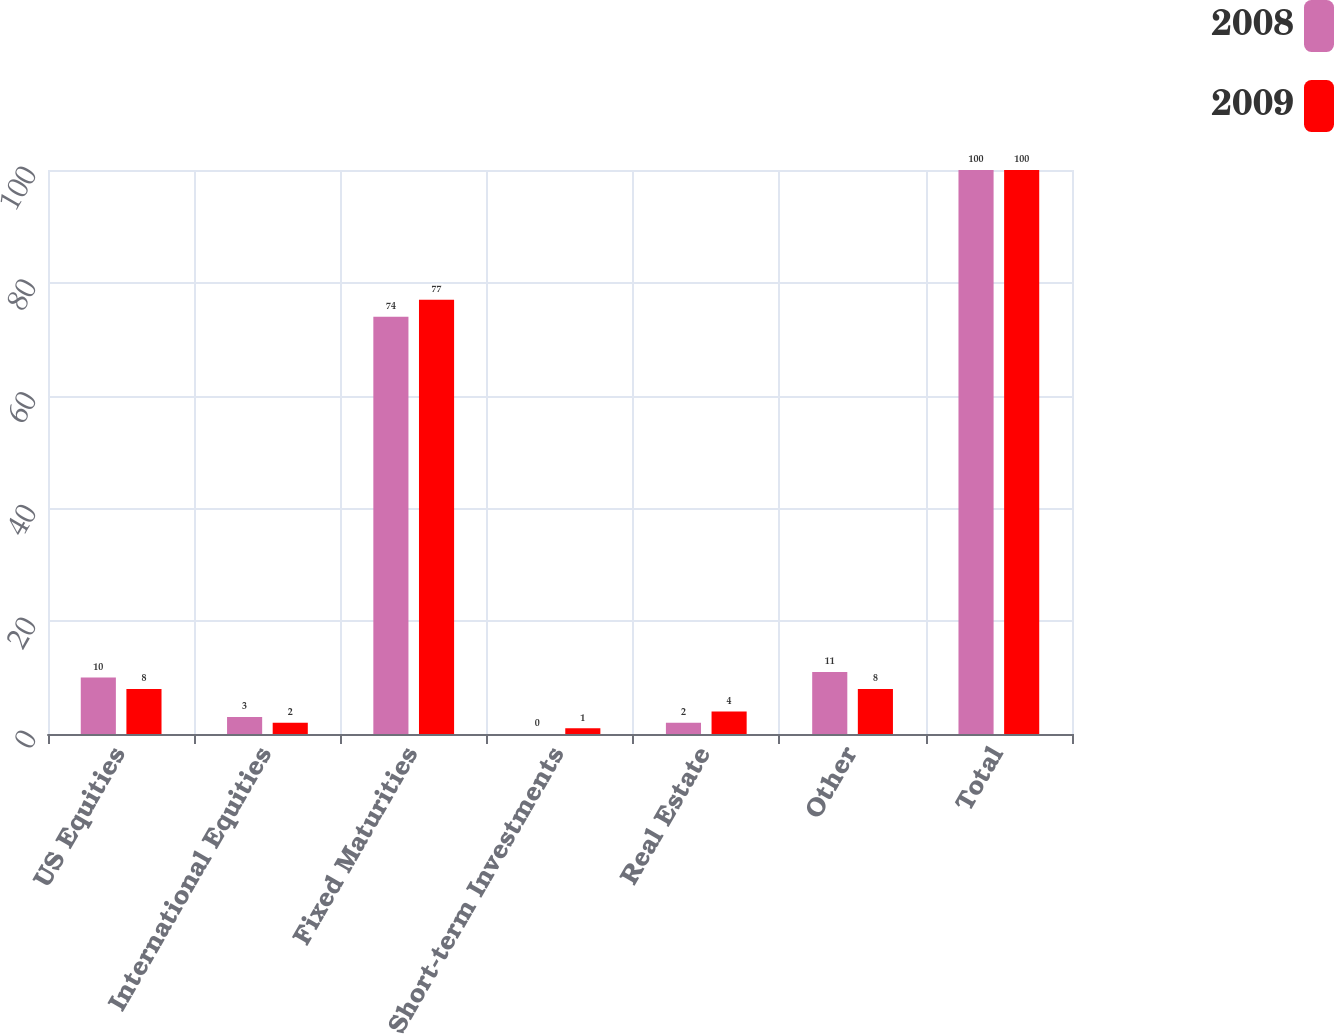Convert chart to OTSL. <chart><loc_0><loc_0><loc_500><loc_500><stacked_bar_chart><ecel><fcel>US Equities<fcel>International Equities<fcel>Fixed Maturities<fcel>Short-term Investments<fcel>Real Estate<fcel>Other<fcel>Total<nl><fcel>2008<fcel>10<fcel>3<fcel>74<fcel>0<fcel>2<fcel>11<fcel>100<nl><fcel>2009<fcel>8<fcel>2<fcel>77<fcel>1<fcel>4<fcel>8<fcel>100<nl></chart> 